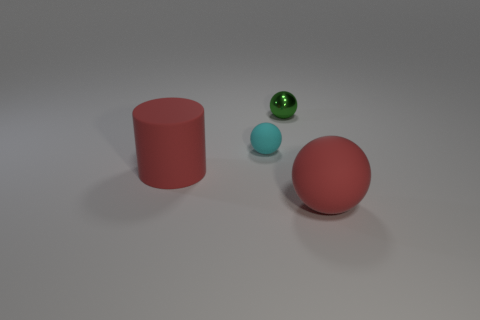Imagine these objects are part of a larger set, what kind of set could that be? Envisioning these objects as parts of a more extensive set, one could imagine them belonging to a child's educational playset designed to teach about shapes, colors, and materials. Alternatively, they might be components from a modernist art installation that explores geometrical forms and the interplay of light on different surfaces. 